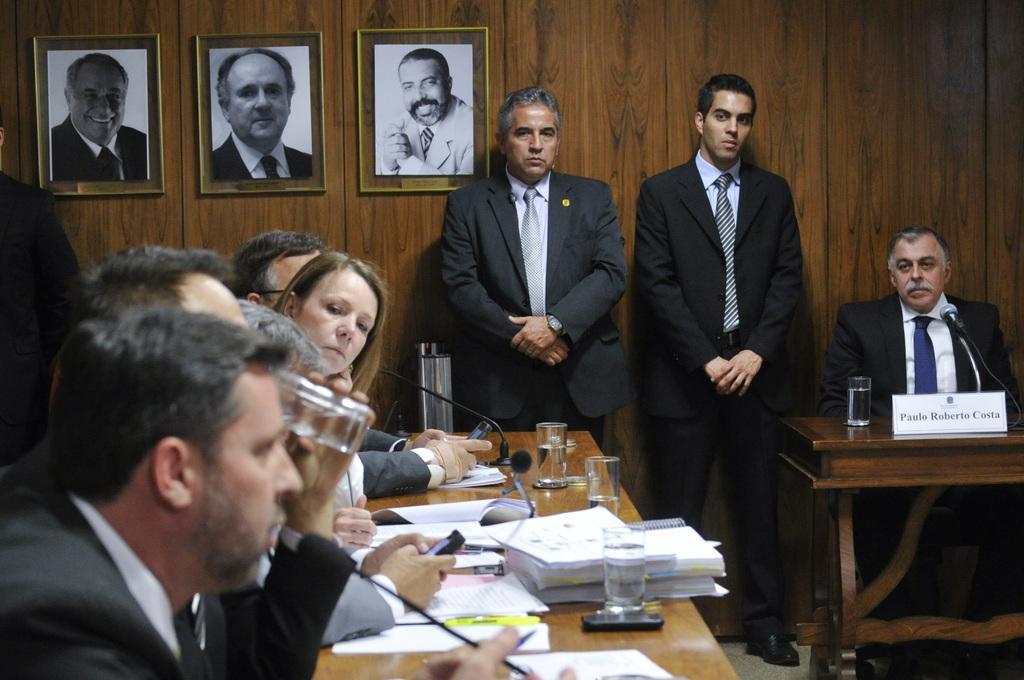In one or two sentences, can you explain what this image depicts? The picture is clicked inside a conference hall where there are several people sitting on the table. In the background we observe two guys standing and listening to them. In the background we observe three photographs attached to the brown wall. There is also a guy to the right side of the image whose name is paulo roberto costa. 